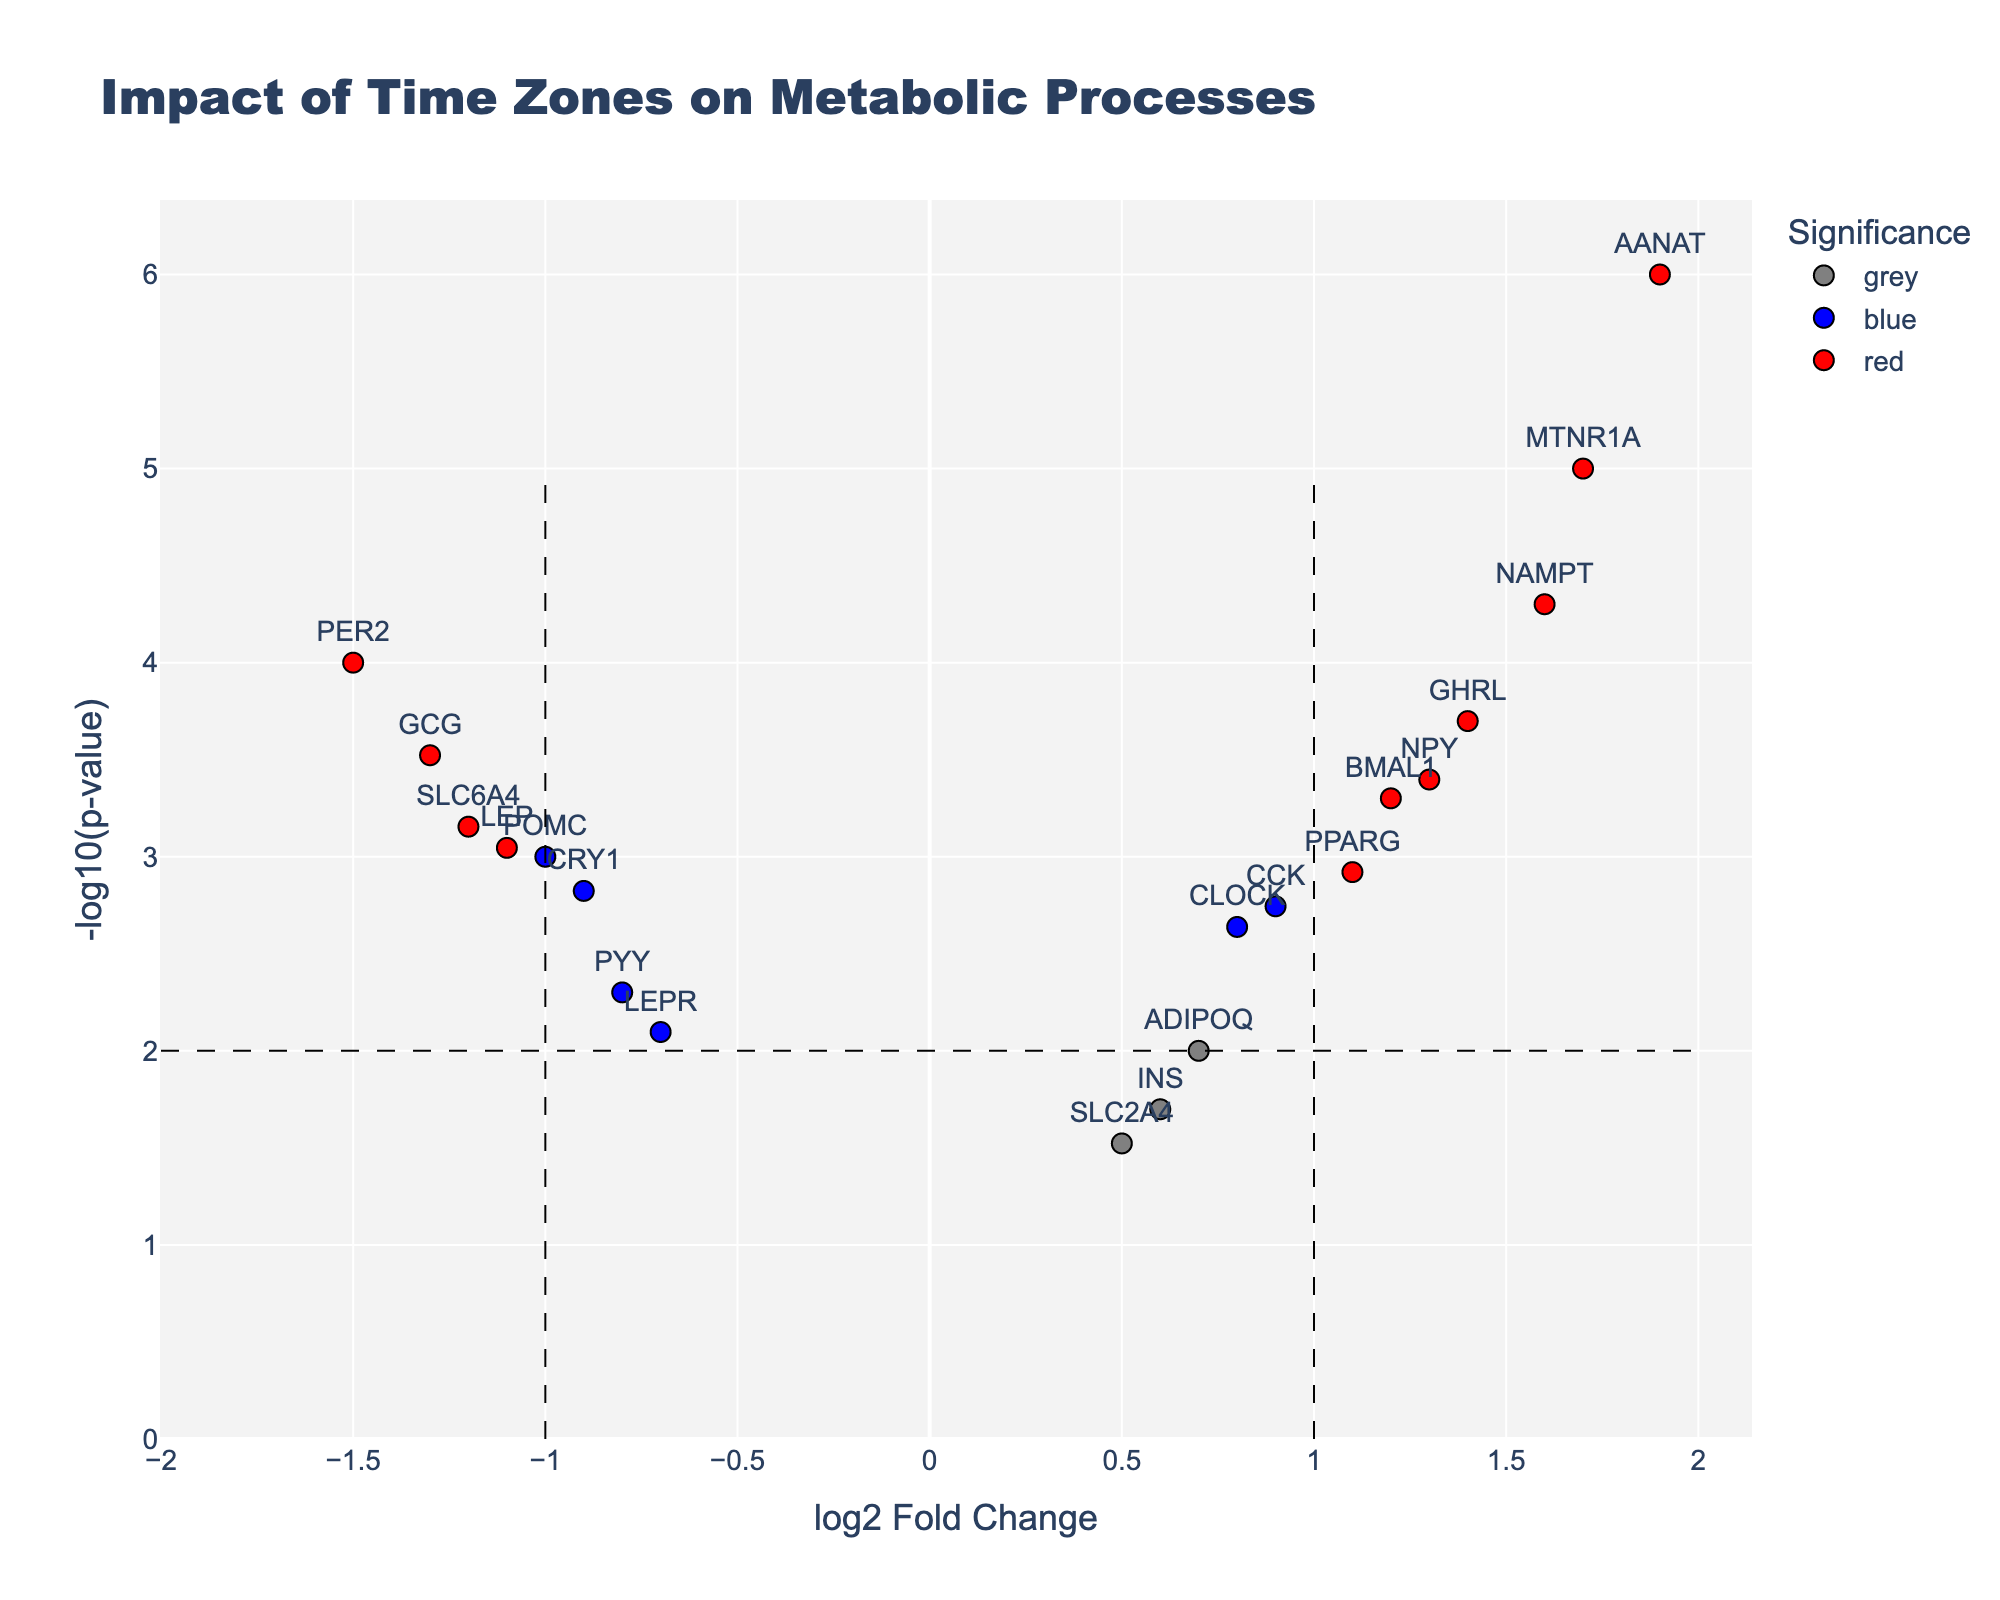Which gene has the highest -log10(p-value)? To find the gene with the highest -log10(p-value), look at the y-axis and identify the gene that reaches the highest point.
Answer: AANAT Which color represents genes with significant changes in log2 fold change but not in p-value? Look at the explanation of colors to find which color signifies genes with significant log2 fold change (>1 or <-1) but with p-values above the significance threshold (0.01).
Answer: Green How many genes have a log2 fold change greater than 0? Count the number of data points (genes) with a log2 fold change above 0 (right side of the x-axis).
Answer: 12 What is the log2 fold change threshold used in the plot? Identify the vertical dashed lines on the plot, which typically represent the fold change threshold.
Answer: 1 Which gene related to digestion has the most significant decrease in expression? Identify the genes related to digestion on the plot and find the one with the most negative log2 fold change and the lowest p-value (highest -log10 of p-value).
Answer: GCG How does the expression of CLOCK and BMAL1 compare regarding significance and fold change? Compare the positions of CLOCK and BMAL1 on the plot in terms of their log2 fold change (x-axis) and -log10(p-value) (y-axis).
Answer: BMAL1 has a higher fold change and significance than CLOCK Which genes have a log2 fold change between -1 and 1 but are still significant? Identify genes with p-values below the significance threshold (p < 0.01) but with log2 fold changes between -1 and 1 (inside the vertical dashed lines).
Answer: CRY1, LEPR, CCK Which gene involved in sleep regulation has the highest fold change? Identify the genes involved in sleep regulation on the plot and find the one with the highest log2 fold change.
Answer: AANAT What is the common characteristic of the red data points? Look at the legend and read the explanation to understand what the color red represents.
Answer: Significant in both fold change and p-value How many digestion-related genes show a significant increase in expression? Look for digestion-related genes that fall in the red category (significant in both metrics) with positive log2 fold change.
Answer: 4 